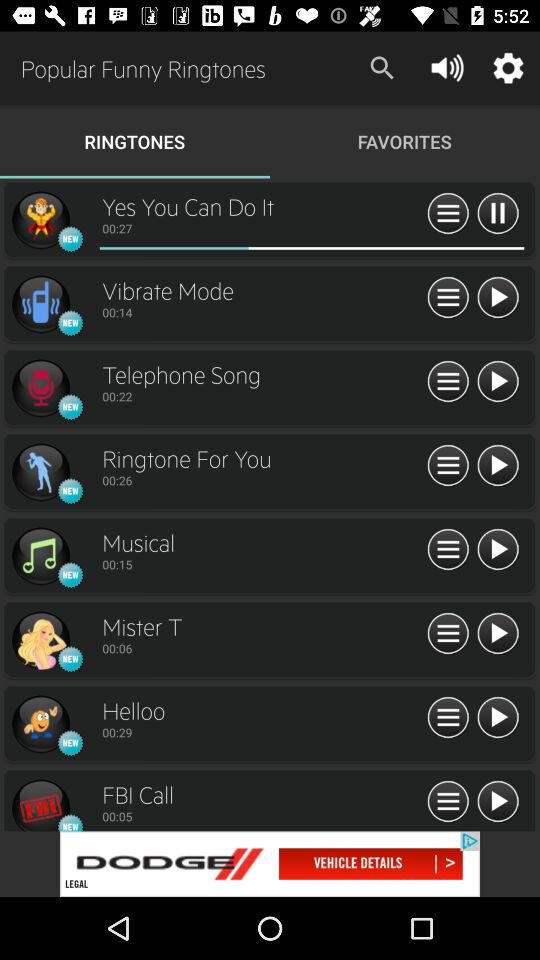How many more seconds are there in the length of the 'Helloo' ringtone than the 'FBI Call' ringtone?
Answer the question using a single word or phrase. 24 